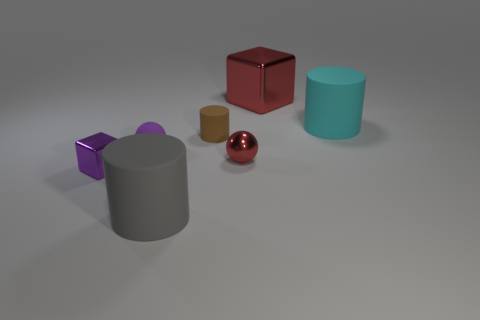Add 2 cyan metal objects. How many objects exist? 9 Subtract all cylinders. How many objects are left? 4 Subtract all small cylinders. Subtract all small rubber objects. How many objects are left? 4 Add 2 big gray matte cylinders. How many big gray matte cylinders are left? 3 Add 7 small red balls. How many small red balls exist? 8 Subtract 1 gray cylinders. How many objects are left? 6 